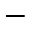Convert formula to latex. <formula><loc_0><loc_0><loc_500><loc_500>-</formula> 